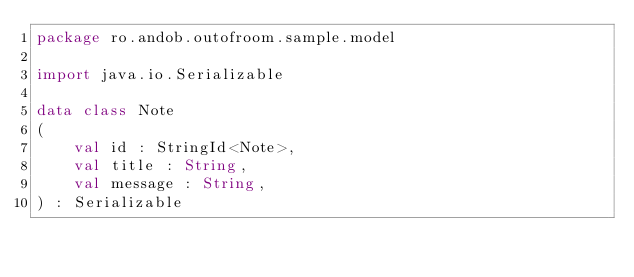Convert code to text. <code><loc_0><loc_0><loc_500><loc_500><_Kotlin_>package ro.andob.outofroom.sample.model

import java.io.Serializable

data class Note
(
    val id : StringId<Note>,
    val title : String,
    val message : String,
) : Serializable
</code> 